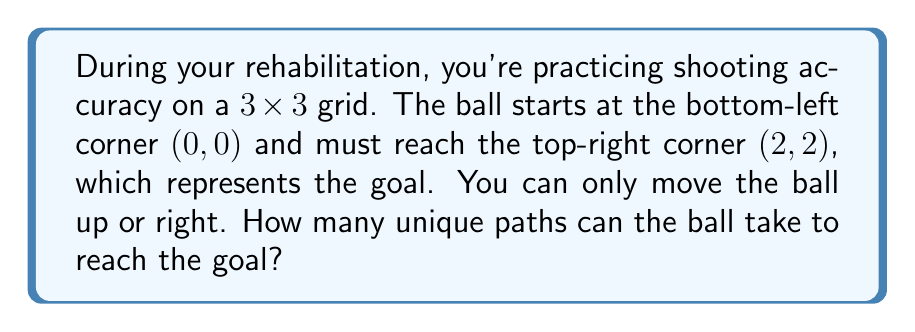Can you answer this question? Let's approach this step-by-step:

1) First, observe that to reach the goal at (2,2) from (0,0), the ball must move:
   - 2 steps to the right
   - 2 steps upward

2) The total number of steps is always 4 (2 right + 2 up).

3) This problem is equivalent to choosing which 2 out of the 4 total steps will be "right" moves (or equivalently, which 2 will be "up" moves).

4) This is a combination problem. We need to calculate $\binom{4}{2}$ or "4 choose 2".

5) The formula for this combination is:

   $$\binom{4}{2} = \frac{4!}{2!(4-2)!} = \frac{4!}{2!2!}$$

6) Let's calculate:
   $$\frac{4 \cdot 3 \cdot 2 \cdot 1}{(2 \cdot 1)(2 \cdot 1)} = \frac{24}{4} = 6$$

Therefore, there are 6 unique paths the ball can take to reach the goal.
Answer: 6 paths 